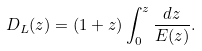<formula> <loc_0><loc_0><loc_500><loc_500>D _ { L } ( z ) = ( 1 + z ) \int _ { 0 } ^ { z } \frac { d { z } } { E ( { z } ) } .</formula> 